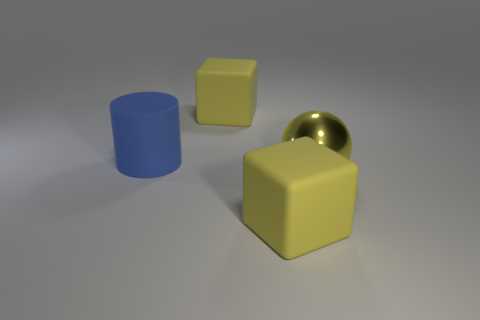Add 4 big things. How many objects exist? 8 Subtract all balls. How many objects are left? 3 Subtract 1 yellow balls. How many objects are left? 3 Subtract all yellow shiny balls. Subtract all rubber things. How many objects are left? 0 Add 3 large rubber objects. How many large rubber objects are left? 6 Add 4 tiny brown things. How many tiny brown things exist? 4 